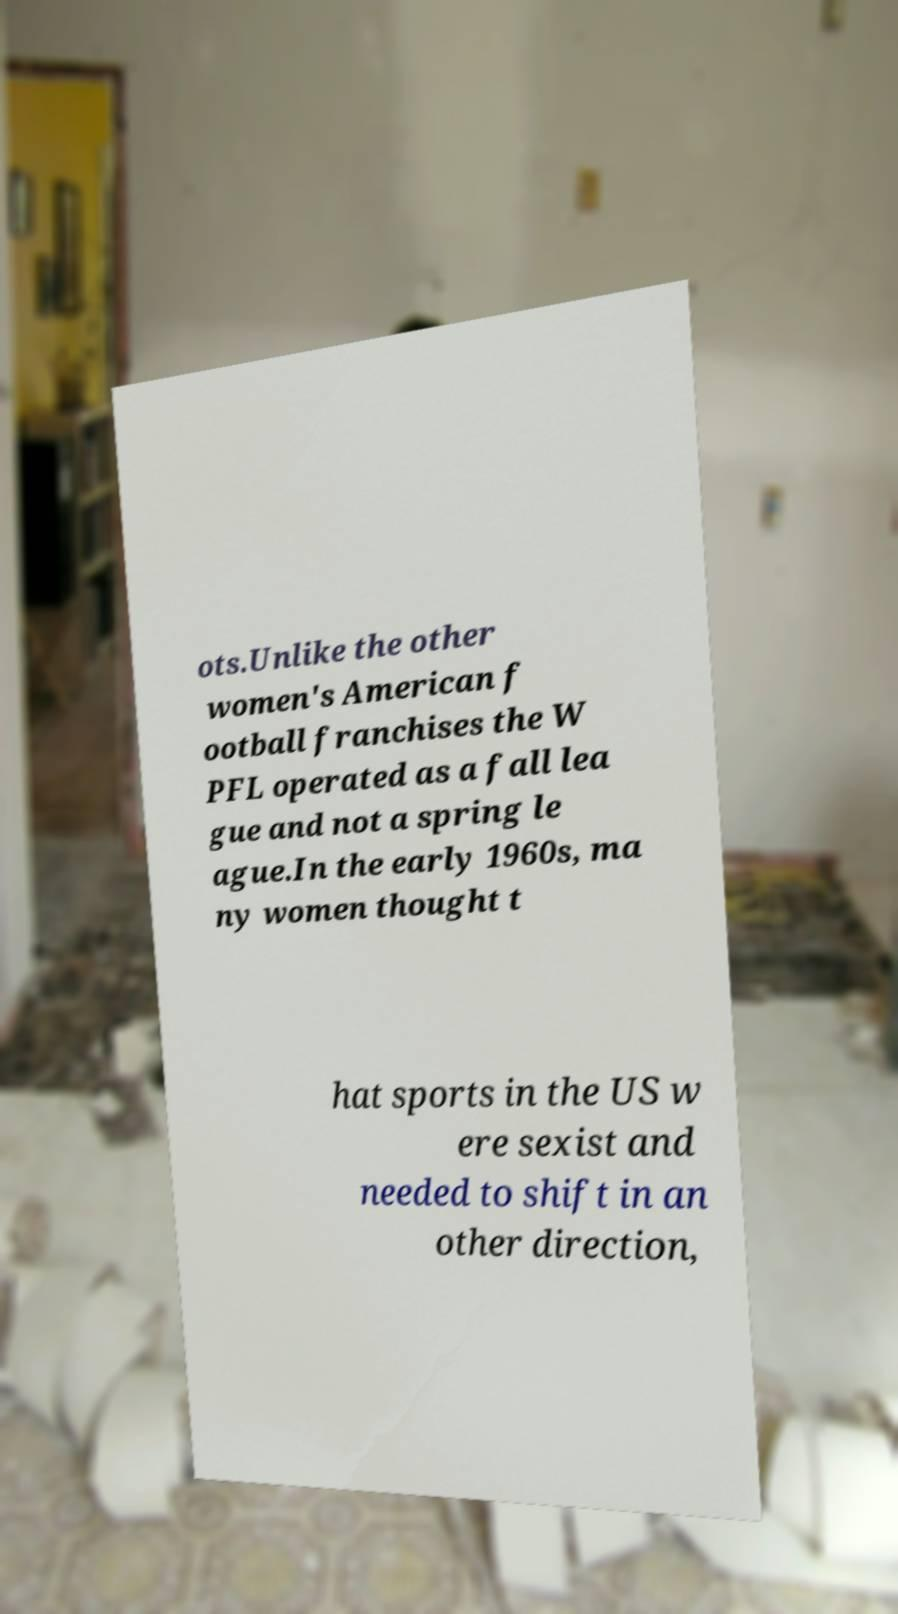Please identify and transcribe the text found in this image. ots.Unlike the other women's American f ootball franchises the W PFL operated as a fall lea gue and not a spring le ague.In the early 1960s, ma ny women thought t hat sports in the US w ere sexist and needed to shift in an other direction, 